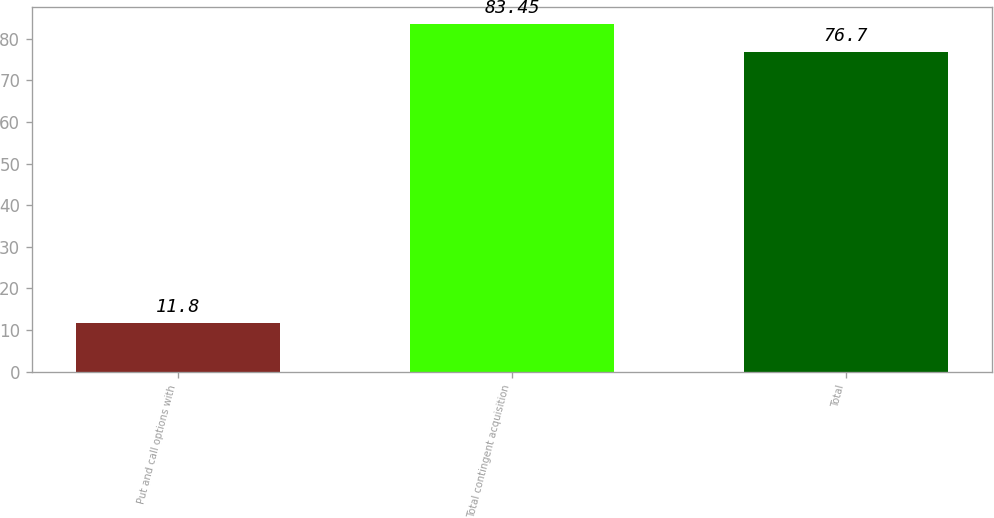Convert chart. <chart><loc_0><loc_0><loc_500><loc_500><bar_chart><fcel>Put and call options with<fcel>Total contingent acquisition<fcel>Total<nl><fcel>11.8<fcel>83.45<fcel>76.7<nl></chart> 